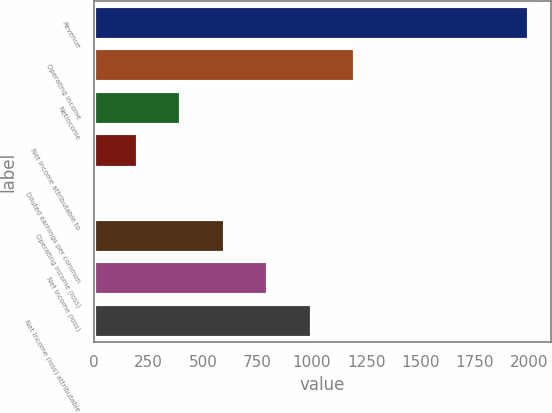Convert chart to OTSL. <chart><loc_0><loc_0><loc_500><loc_500><bar_chart><fcel>Revenue<fcel>Operating income<fcel>Netincome<fcel>Net income attributable to<fcel>Diluted earnings per common<fcel>Operating income (loss)<fcel>Net income (loss)<fcel>Net income (loss) attributable<nl><fcel>1999<fcel>1199.43<fcel>399.87<fcel>199.98<fcel>0.09<fcel>599.76<fcel>799.65<fcel>999.54<nl></chart> 